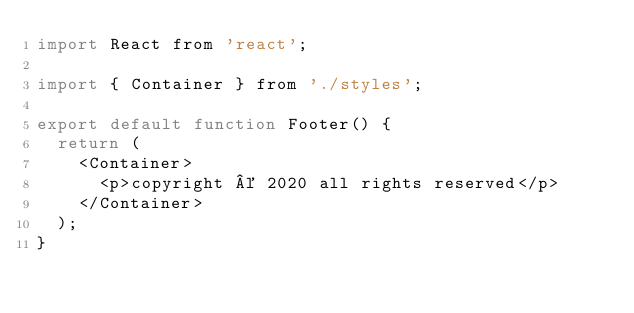Convert code to text. <code><loc_0><loc_0><loc_500><loc_500><_JavaScript_>import React from 'react';

import { Container } from './styles';

export default function Footer() {
  return (
    <Container>
      <p>copyright © 2020 all rights reserved</p>
    </Container>
  );
}
</code> 